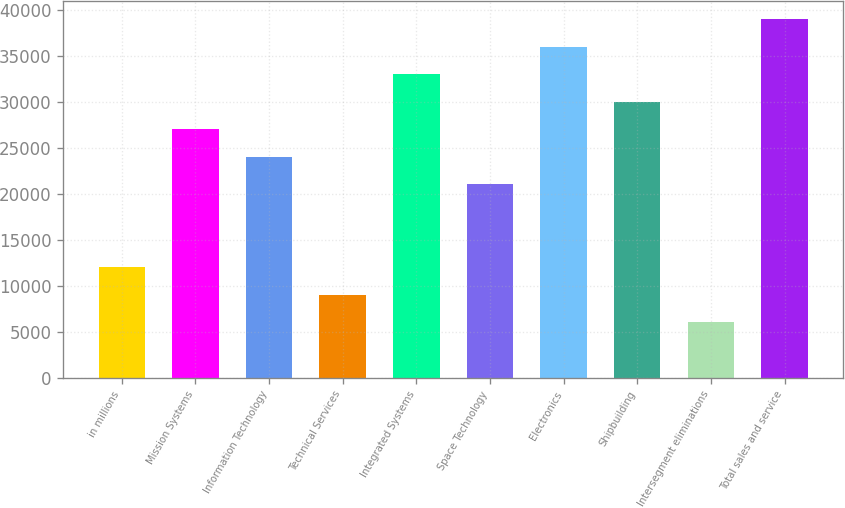Convert chart. <chart><loc_0><loc_0><loc_500><loc_500><bar_chart><fcel>in millions<fcel>Mission Systems<fcel>Information Technology<fcel>Technical Services<fcel>Integrated Systems<fcel>Space Technology<fcel>Electronics<fcel>Shipbuilding<fcel>Intersegment eliminations<fcel>Total sales and service<nl><fcel>12007.8<fcel>26993.8<fcel>23996.6<fcel>9010.6<fcel>32988.2<fcel>20999.4<fcel>35985.4<fcel>29991<fcel>6013.4<fcel>38982.6<nl></chart> 